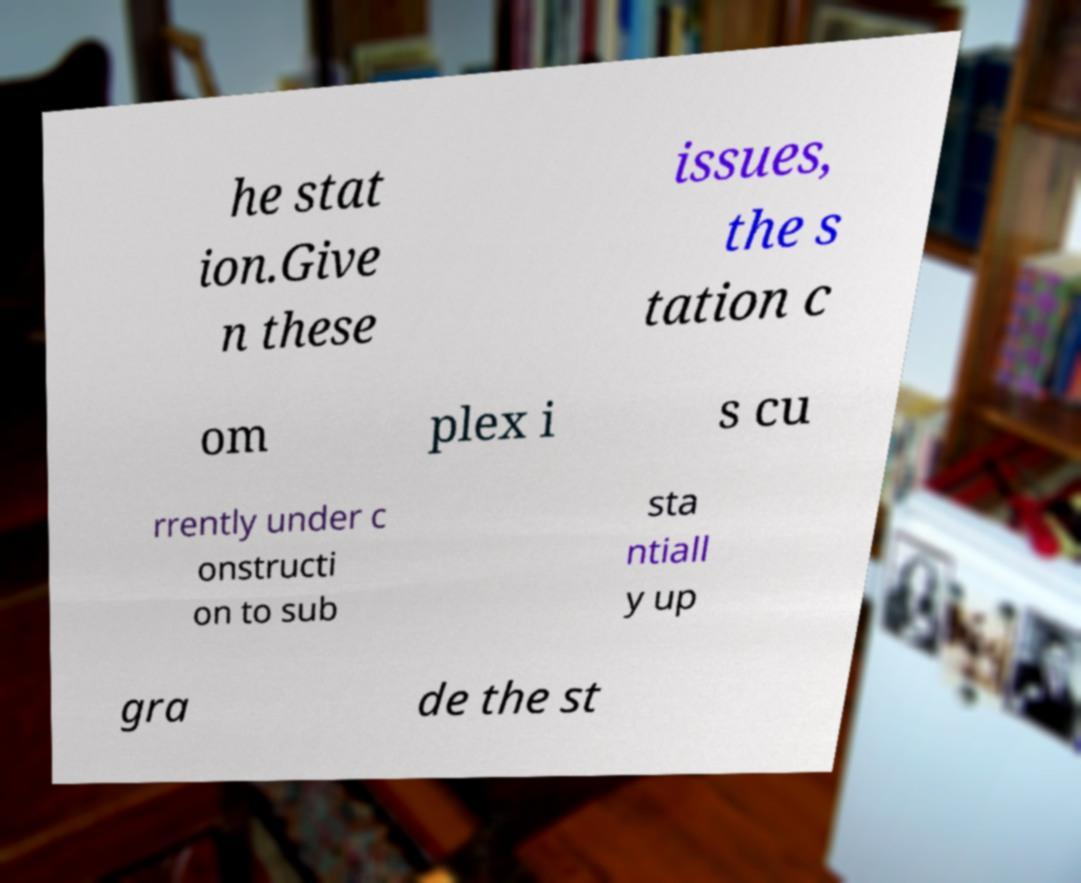Could you assist in decoding the text presented in this image and type it out clearly? he stat ion.Give n these issues, the s tation c om plex i s cu rrently under c onstructi on to sub sta ntiall y up gra de the st 